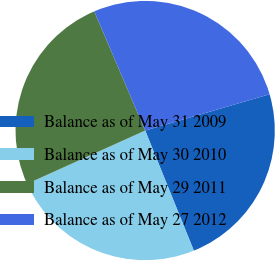<chart> <loc_0><loc_0><loc_500><loc_500><pie_chart><fcel>Balance as of May 31 2009<fcel>Balance as of May 30 2010<fcel>Balance as of May 29 2011<fcel>Balance as of May 27 2012<nl><fcel>23.39%<fcel>24.38%<fcel>25.32%<fcel>26.91%<nl></chart> 